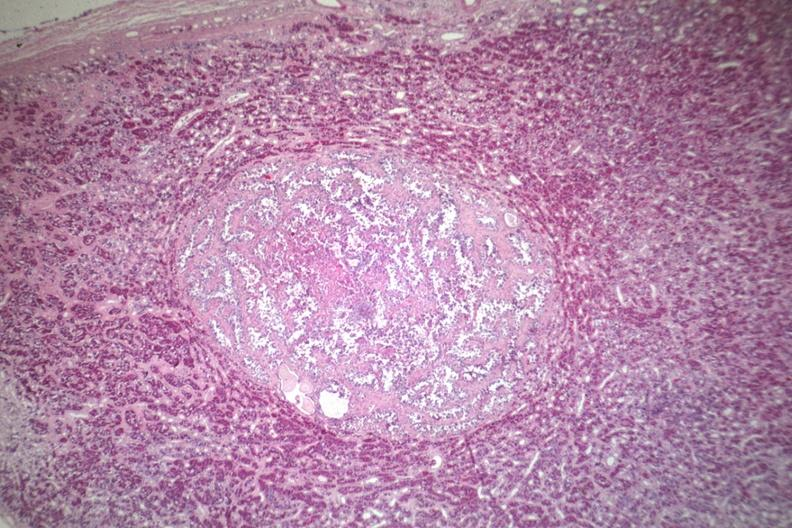what is present?
Answer the question using a single word or phrase. Endocrine 